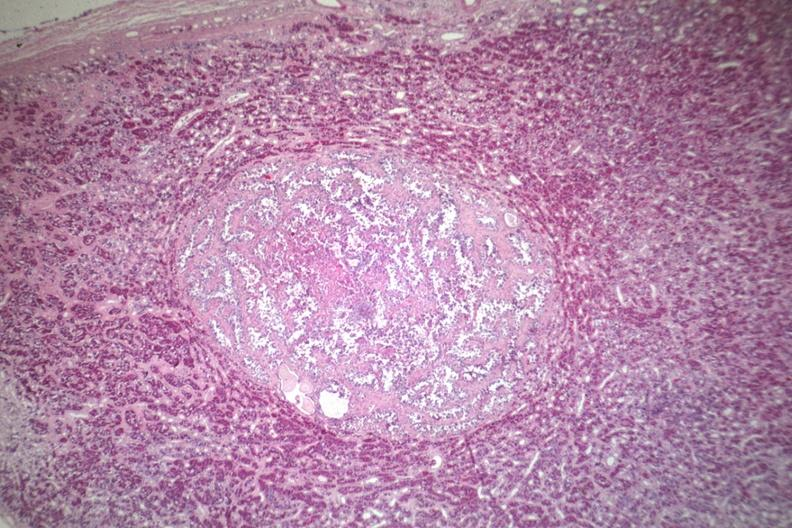what is present?
Answer the question using a single word or phrase. Endocrine 